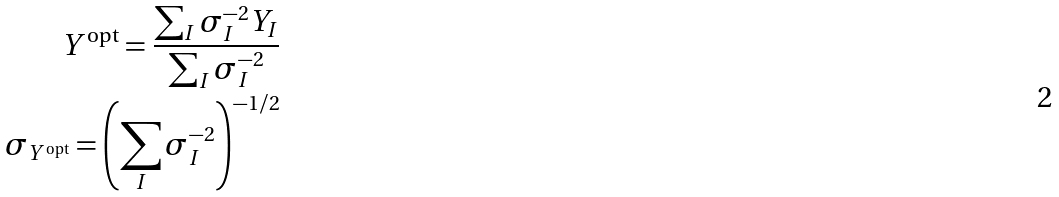Convert formula to latex. <formula><loc_0><loc_0><loc_500><loc_500>Y ^ { \text {opt} } = \frac { \sum _ { I } \sigma _ { I } ^ { - 2 } Y _ { I } } { \sum _ { I } \sigma _ { I } ^ { - 2 } } \\ \sigma _ { Y ^ { \text {opt} } } = \left ( { \sum _ { I } \sigma _ { I } ^ { - 2 } } \right ) ^ { - 1 / 2 }</formula> 